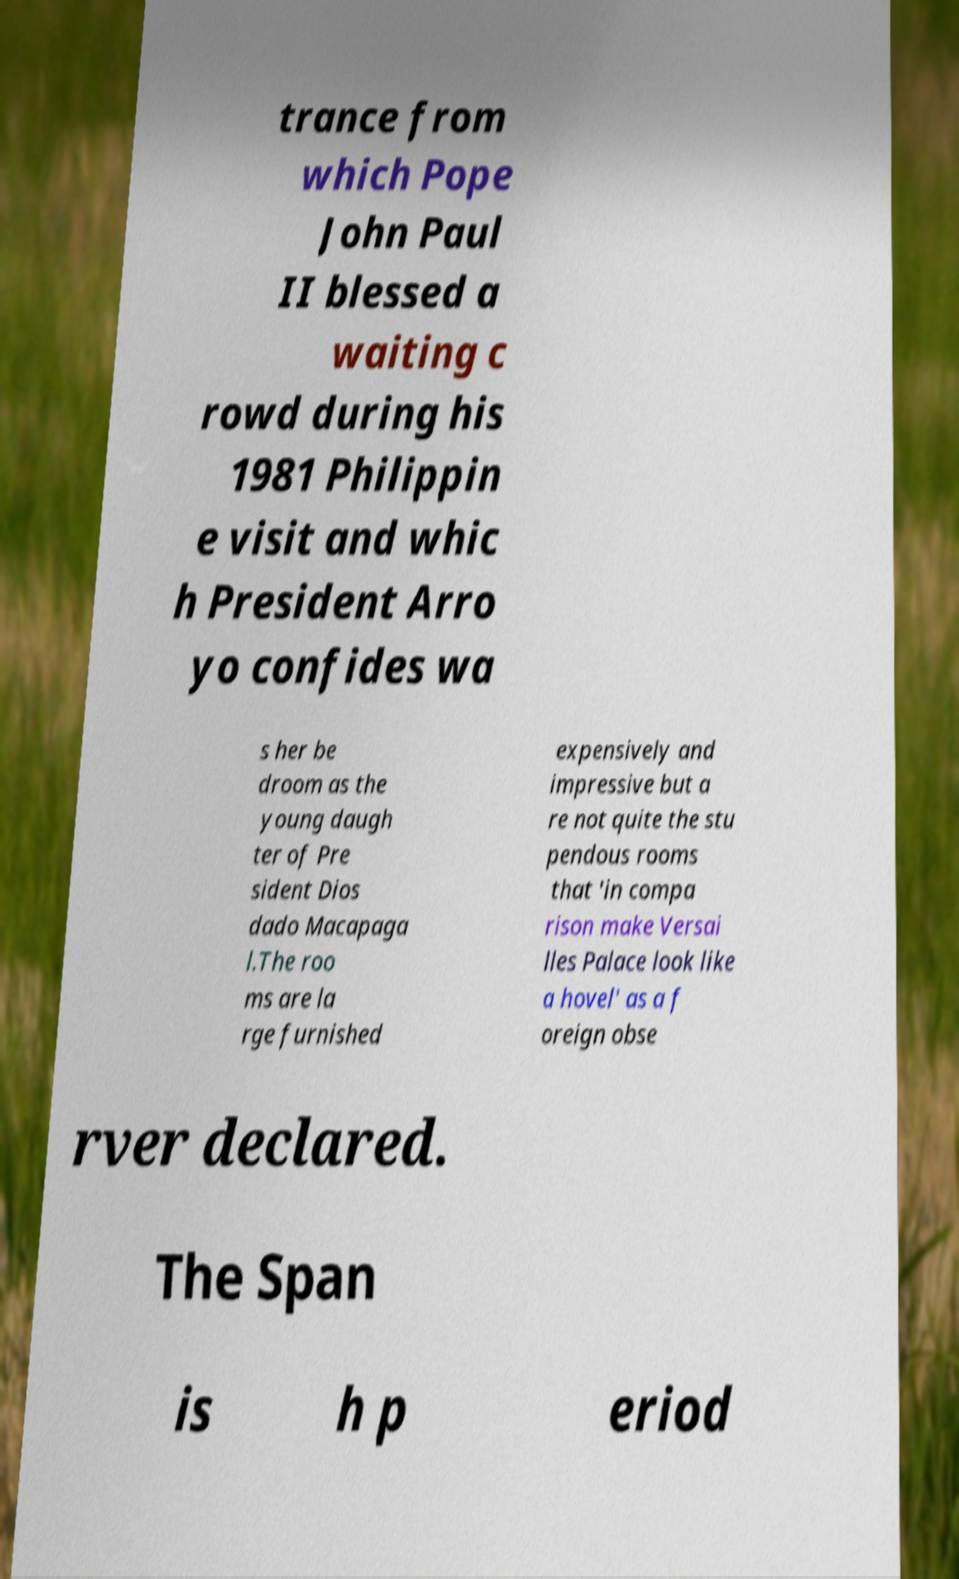There's text embedded in this image that I need extracted. Can you transcribe it verbatim? trance from which Pope John Paul II blessed a waiting c rowd during his 1981 Philippin e visit and whic h President Arro yo confides wa s her be droom as the young daugh ter of Pre sident Dios dado Macapaga l.The roo ms are la rge furnished expensively and impressive but a re not quite the stu pendous rooms that 'in compa rison make Versai lles Palace look like a hovel' as a f oreign obse rver declared. The Span is h p eriod 